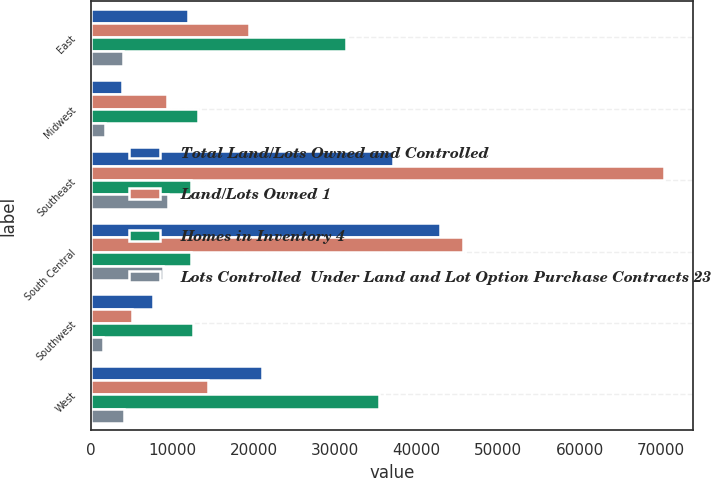Convert chart. <chart><loc_0><loc_0><loc_500><loc_500><stacked_bar_chart><ecel><fcel>East<fcel>Midwest<fcel>Southeast<fcel>South Central<fcel>Southwest<fcel>West<nl><fcel>Total Land/Lots Owned and Controlled<fcel>11900<fcel>3800<fcel>37100<fcel>42900<fcel>7600<fcel>21000<nl><fcel>Land/Lots Owned 1<fcel>19400<fcel>9300<fcel>70400<fcel>45700<fcel>5000<fcel>14400<nl><fcel>Homes in Inventory 4<fcel>31300<fcel>13100<fcel>12250<fcel>12250<fcel>12600<fcel>35400<nl><fcel>Lots Controlled  Under Land and Lot Option Purchase Contracts 23<fcel>4000<fcel>1800<fcel>9500<fcel>8800<fcel>1500<fcel>4100<nl></chart> 